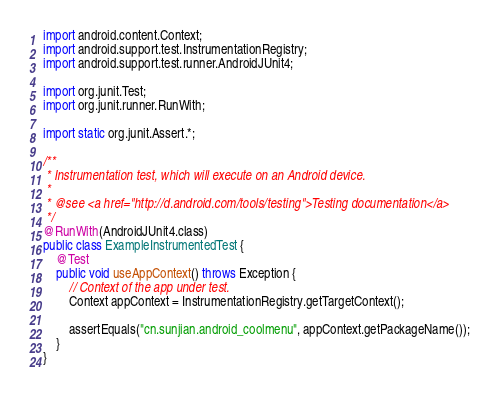<code> <loc_0><loc_0><loc_500><loc_500><_Java_>
import android.content.Context;
import android.support.test.InstrumentationRegistry;
import android.support.test.runner.AndroidJUnit4;

import org.junit.Test;
import org.junit.runner.RunWith;

import static org.junit.Assert.*;

/**
 * Instrumentation test, which will execute on an Android device.
 *
 * @see <a href="http://d.android.com/tools/testing">Testing documentation</a>
 */
@RunWith(AndroidJUnit4.class)
public class ExampleInstrumentedTest {
    @Test
    public void useAppContext() throws Exception {
        // Context of the app under test.
        Context appContext = InstrumentationRegistry.getTargetContext();

        assertEquals("cn.sunjian.android_coolmenu", appContext.getPackageName());
    }
}
</code> 